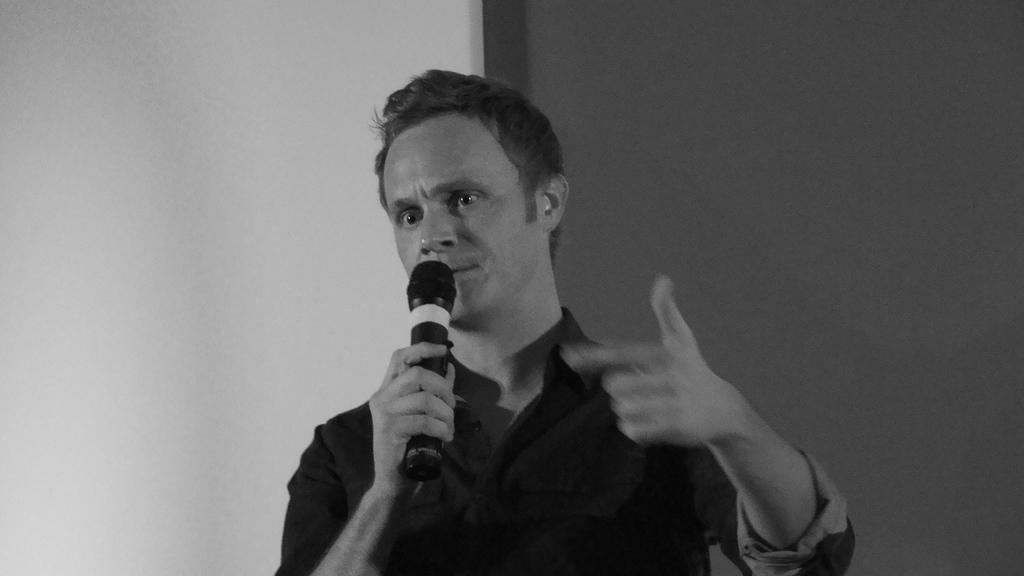What is the main subject of the image? There is a man in the image. What is the man holding in the image? The man is holding a mic. What type of plants can be seen growing on the man's back in the image? There are no plants visible on the man's back in the image. What is the man using to brush his teeth in the image? There is no toothbrush present in the image. 